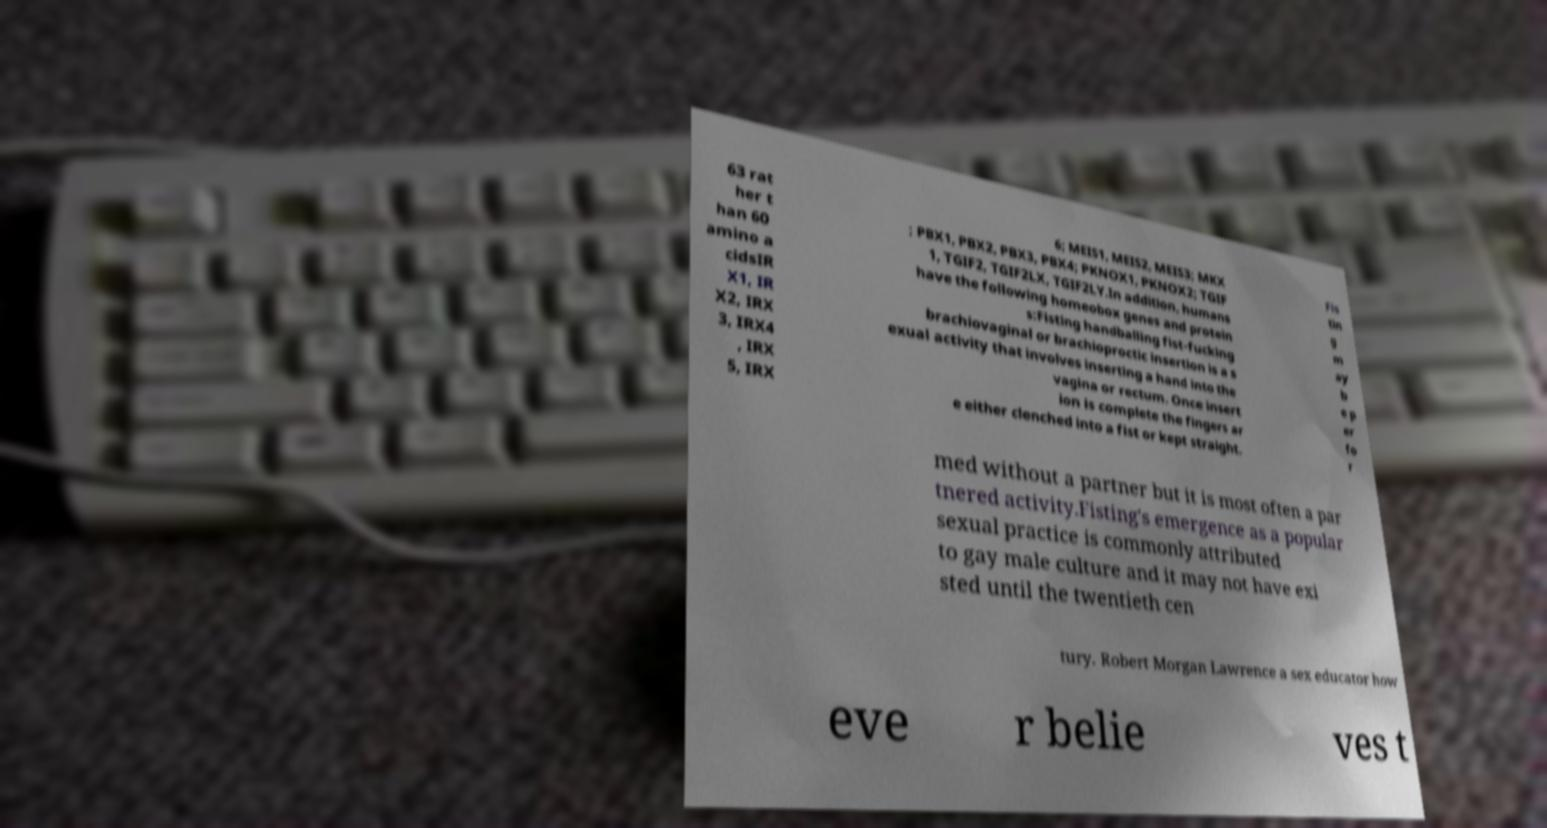Could you extract and type out the text from this image? 63 rat her t han 60 amino a cidsIR X1, IR X2, IRX 3, IRX4 , IRX 5, IRX 6; MEIS1, MEIS2, MEIS3; MKX ; PBX1, PBX2, PBX3, PBX4; PKNOX1, PKNOX2; TGIF 1, TGIF2, TGIF2LX, TGIF2LY.In addition, humans have the following homeobox genes and protein s:Fisting handballing fist-fucking brachiovaginal or brachioproctic insertion is a s exual activity that involves inserting a hand into the vagina or rectum. Once insert ion is complete the fingers ar e either clenched into a fist or kept straight. Fis tin g m ay b e p er fo r med without a partner but it is most often a par tnered activity.Fisting's emergence as a popular sexual practice is commonly attributed to gay male culture and it may not have exi sted until the twentieth cen tury. Robert Morgan Lawrence a sex educator how eve r belie ves t 